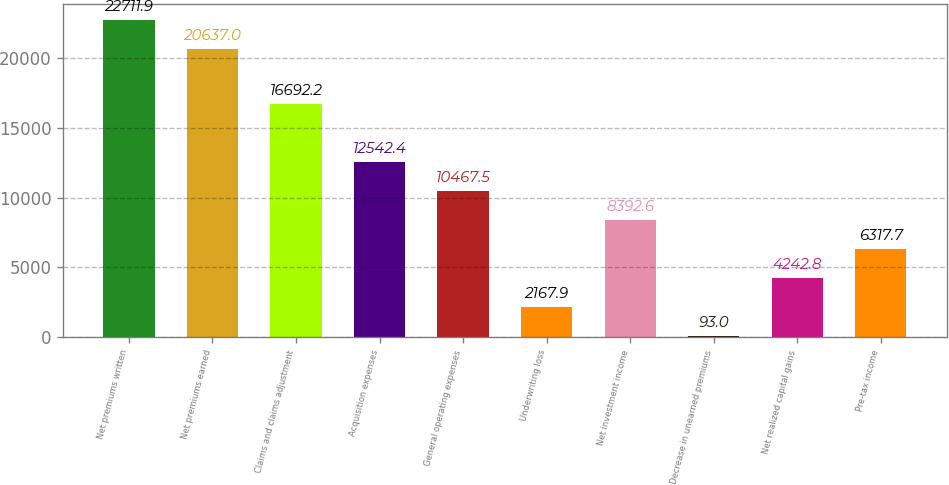Convert chart. <chart><loc_0><loc_0><loc_500><loc_500><bar_chart><fcel>Net premiums written<fcel>Net premiums earned<fcel>Claims and claims adjustment<fcel>Acquisition expenses<fcel>General operating expenses<fcel>Underwriting loss<fcel>Net investment income<fcel>Decrease in unearned premiums<fcel>Net realized capital gains<fcel>Pre-tax income<nl><fcel>22711.9<fcel>20637<fcel>16692.2<fcel>12542.4<fcel>10467.5<fcel>2167.9<fcel>8392.6<fcel>93<fcel>4242.8<fcel>6317.7<nl></chart> 